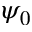Convert formula to latex. <formula><loc_0><loc_0><loc_500><loc_500>\psi _ { 0 }</formula> 